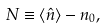<formula> <loc_0><loc_0><loc_500><loc_500>N \equiv \left \langle \hat { n } \right \rangle - n _ { 0 } ,</formula> 